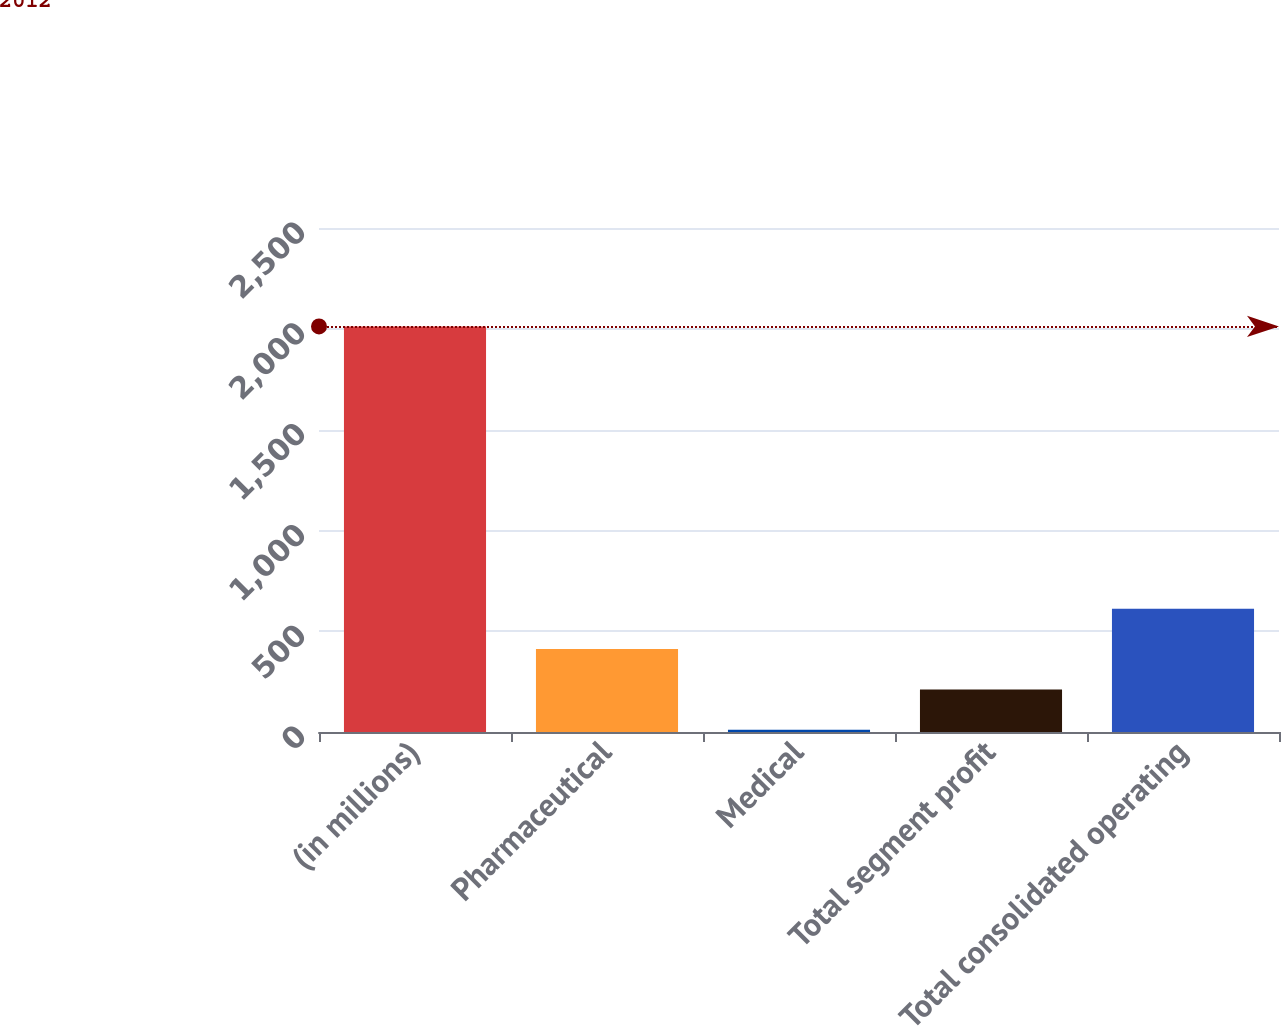<chart> <loc_0><loc_0><loc_500><loc_500><bar_chart><fcel>(in millions)<fcel>Pharmaceutical<fcel>Medical<fcel>Total segment profit<fcel>Total consolidated operating<nl><fcel>2012<fcel>411.2<fcel>11<fcel>211.1<fcel>611.3<nl></chart> 